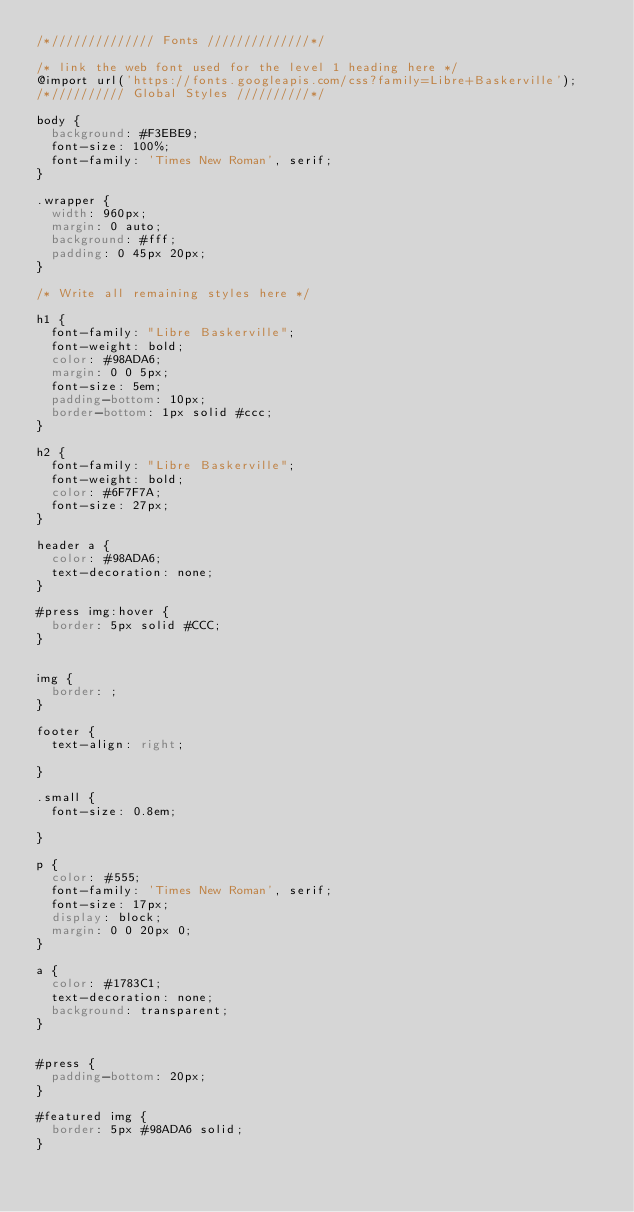Convert code to text. <code><loc_0><loc_0><loc_500><loc_500><_CSS_>/*////////////// Fonts //////////////*/

/* link the web font used for the level 1 heading here */
@import url('https://fonts.googleapis.com/css?family=Libre+Baskerville');
/*////////// Global Styles //////////*/

body {
	background: #F3EBE9;
	font-size: 100%;
	font-family: 'Times New Roman', serif; 
}

.wrapper {
	width: 960px;
	margin: 0 auto;
	background: #fff;
	padding: 0 45px 20px;
}

/* Write all remaining styles here */

h1 {
	font-family: "Libre Baskerville";
	font-weight: bold;
	color: #98ADA6;
	margin: 0 0 5px;
	font-size: 5em;
	padding-bottom: 10px; 
	border-bottom: 1px solid #ccc;
}

h2 {
	font-family: "Libre Baskerville";
	font-weight: bold;
	color: #6F7F7A;
	font-size: 27px;
}

header a {
	color: #98ADA6;
	text-decoration: none;
}

#press img:hover {
	border: 5px solid #CCC;
}


img {
	border: ;
}

footer {
	text-align: right;
	
}

.small {
	font-size: 0.8em;
	
}

p {
	color: #555;
	font-family: 'Times New Roman', serif;
	font-size: 17px;
	display: block;
	margin: 0 0 20px 0;
}

a {
	color: #1783C1;
	text-decoration: none;
	background: transparent;
}


#press {
	padding-bottom: 20px;
}

#featured img {
	border: 5px #98ADA6 solid;
}



</code> 